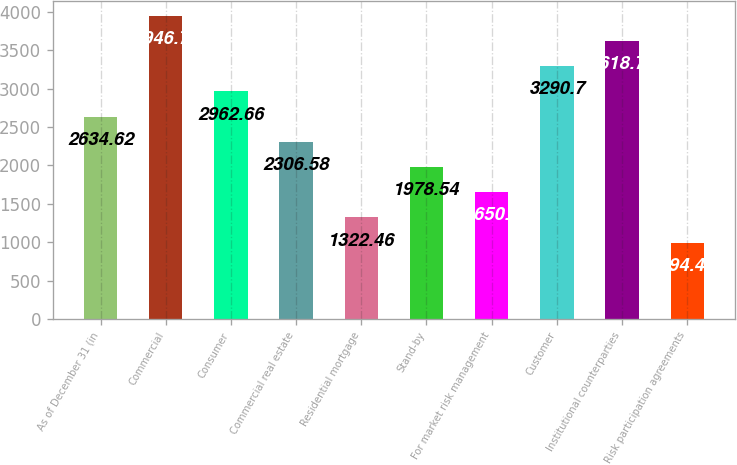Convert chart to OTSL. <chart><loc_0><loc_0><loc_500><loc_500><bar_chart><fcel>As of December 31 (in<fcel>Commercial<fcel>Consumer<fcel>Commercial real estate<fcel>Residential mortgage<fcel>Stand-by<fcel>For market risk management<fcel>Customer<fcel>Institutional counterparties<fcel>Risk participation agreements<nl><fcel>2634.62<fcel>3946.78<fcel>2962.66<fcel>2306.58<fcel>1322.46<fcel>1978.54<fcel>1650.5<fcel>3290.7<fcel>3618.74<fcel>994.42<nl></chart> 